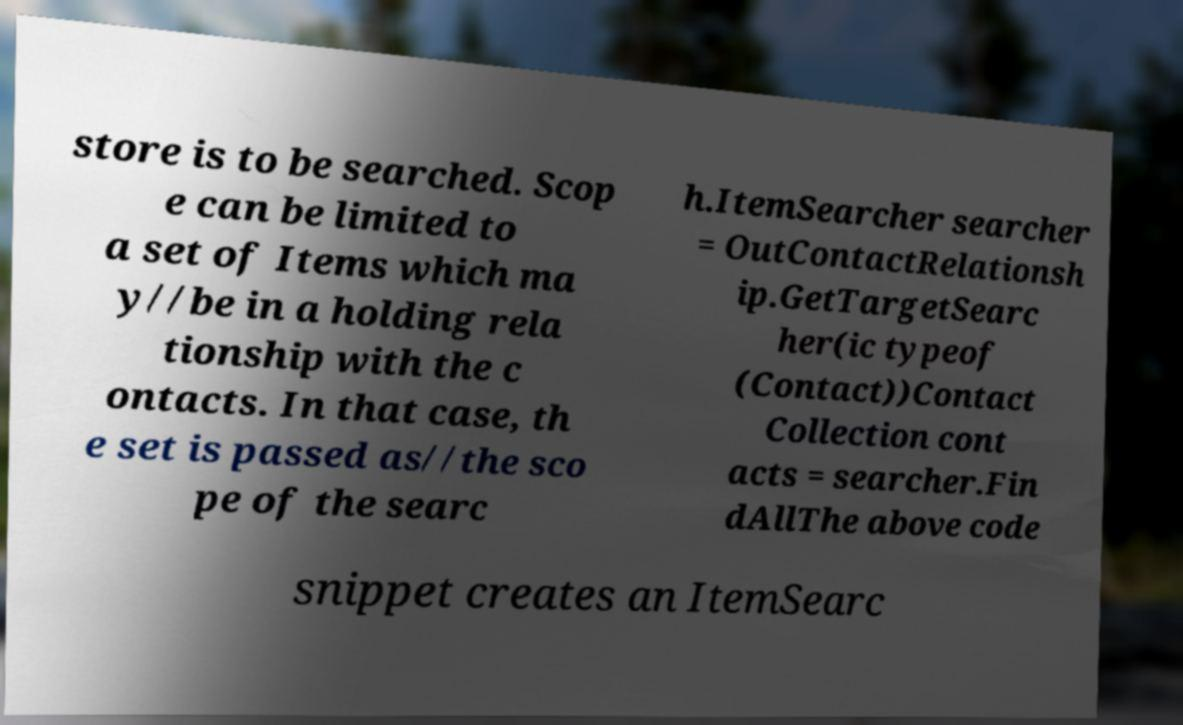Could you assist in decoding the text presented in this image and type it out clearly? store is to be searched. Scop e can be limited to a set of Items which ma y//be in a holding rela tionship with the c ontacts. In that case, th e set is passed as//the sco pe of the searc h.ItemSearcher searcher = OutContactRelationsh ip.GetTargetSearc her(ic typeof (Contact))Contact Collection cont acts = searcher.Fin dAllThe above code snippet creates an ItemSearc 